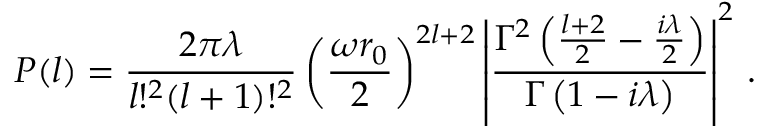<formula> <loc_0><loc_0><loc_500><loc_500>P ( l ) = \frac { 2 \pi \lambda } { l ! ^ { 2 } ( l + 1 ) ! ^ { 2 } } \left ( \frac { \omega r _ { 0 } } { 2 } \right ) ^ { 2 l + 2 } \left | \frac { \Gamma ^ { 2 } \left ( \frac { l + 2 } { 2 } - \frac { i \lambda } { 2 } \right ) } { \Gamma \left ( 1 - i \lambda \right ) } \right | ^ { 2 } \, .</formula> 